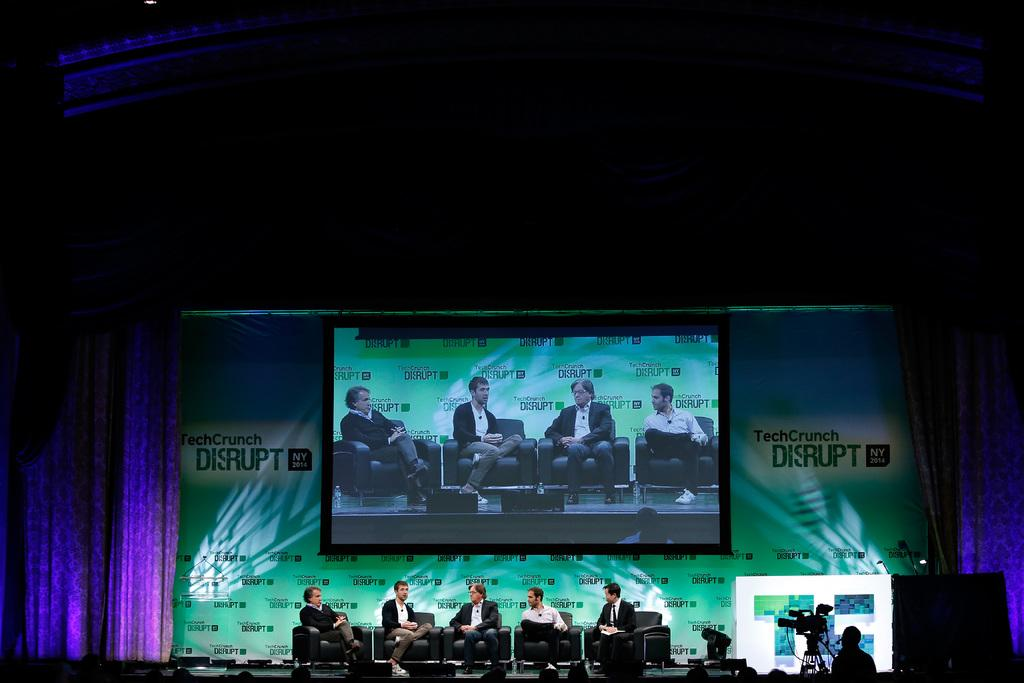Provide a one-sentence caption for the provided image. a conference with several people sitting on chairs on a stage and screen that says TechCrunch Disrupt NY 2014 on the background. 